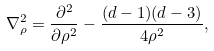Convert formula to latex. <formula><loc_0><loc_0><loc_500><loc_500>{ \nabla } ^ { 2 } _ { \rho } = \frac { \partial ^ { 2 } } { \partial \rho ^ { 2 } } - \frac { ( d - 1 ) ( d - 3 ) } { 4 \rho ^ { 2 } } ,</formula> 